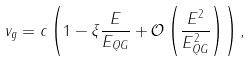Convert formula to latex. <formula><loc_0><loc_0><loc_500><loc_500>v _ { g } = c \left ( 1 - \xi \frac { E } { E _ { Q G } } + \mathcal { O } \left ( \frac { E ^ { 2 } } { E _ { Q G } ^ { 2 } } \right ) \right ) ,</formula> 